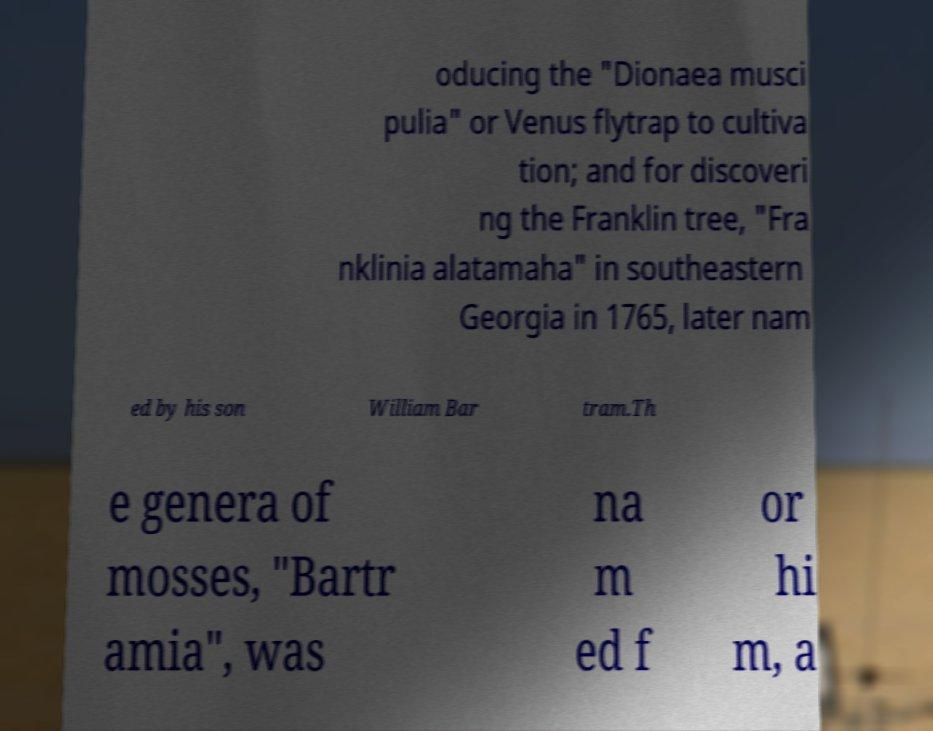Please read and relay the text visible in this image. What does it say? oducing the "Dionaea musci pulia" or Venus flytrap to cultiva tion; and for discoveri ng the Franklin tree, "Fra nklinia alatamaha" in southeastern Georgia in 1765, later nam ed by his son William Bar tram.Th e genera of mosses, "Bartr amia", was na m ed f or hi m, a 